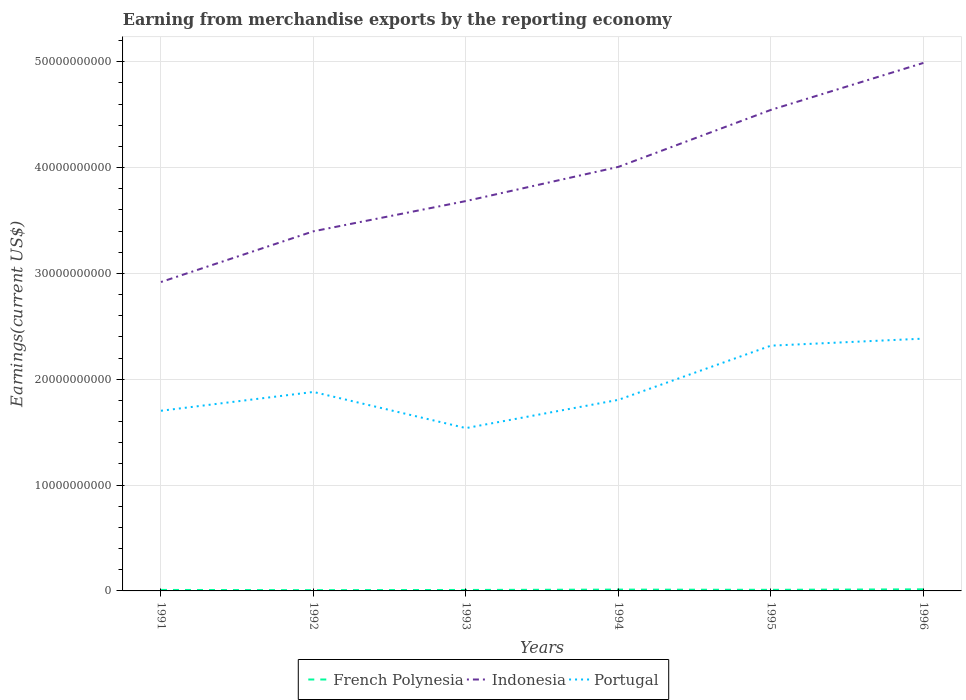Does the line corresponding to Indonesia intersect with the line corresponding to French Polynesia?
Your answer should be very brief. No. Is the number of lines equal to the number of legend labels?
Offer a very short reply. Yes. Across all years, what is the maximum amount earned from merchandise exports in Indonesia?
Your response must be concise. 2.92e+1. In which year was the amount earned from merchandise exports in French Polynesia maximum?
Your answer should be very brief. 1992. What is the total amount earned from merchandise exports in French Polynesia in the graph?
Keep it short and to the point. -1.26e+07. What is the difference between the highest and the second highest amount earned from merchandise exports in Portugal?
Your response must be concise. 8.45e+09. What is the difference between the highest and the lowest amount earned from merchandise exports in Portugal?
Your answer should be compact. 2. Is the amount earned from merchandise exports in French Polynesia strictly greater than the amount earned from merchandise exports in Portugal over the years?
Your response must be concise. Yes. How many lines are there?
Provide a succinct answer. 3. How many years are there in the graph?
Provide a succinct answer. 6. Does the graph contain any zero values?
Ensure brevity in your answer.  No. Does the graph contain grids?
Make the answer very short. Yes. Where does the legend appear in the graph?
Provide a short and direct response. Bottom center. How are the legend labels stacked?
Ensure brevity in your answer.  Horizontal. What is the title of the graph?
Your answer should be compact. Earning from merchandise exports by the reporting economy. What is the label or title of the X-axis?
Provide a short and direct response. Years. What is the label or title of the Y-axis?
Provide a succinct answer. Earnings(current US$). What is the Earnings(current US$) in French Polynesia in 1991?
Give a very brief answer. 9.38e+07. What is the Earnings(current US$) of Indonesia in 1991?
Offer a very short reply. 2.92e+1. What is the Earnings(current US$) in Portugal in 1991?
Offer a very short reply. 1.70e+1. What is the Earnings(current US$) in French Polynesia in 1992?
Provide a succinct answer. 7.24e+07. What is the Earnings(current US$) in Indonesia in 1992?
Offer a terse response. 3.40e+1. What is the Earnings(current US$) of Portugal in 1992?
Your answer should be compact. 1.88e+1. What is the Earnings(current US$) in French Polynesia in 1993?
Offer a terse response. 9.19e+07. What is the Earnings(current US$) of Indonesia in 1993?
Offer a terse response. 3.68e+1. What is the Earnings(current US$) of Portugal in 1993?
Give a very brief answer. 1.54e+1. What is the Earnings(current US$) of French Polynesia in 1994?
Give a very brief answer. 1.24e+08. What is the Earnings(current US$) in Indonesia in 1994?
Your response must be concise. 4.01e+1. What is the Earnings(current US$) in Portugal in 1994?
Your answer should be very brief. 1.81e+1. What is the Earnings(current US$) of French Polynesia in 1995?
Provide a short and direct response. 1.05e+08. What is the Earnings(current US$) in Indonesia in 1995?
Make the answer very short. 4.55e+1. What is the Earnings(current US$) of Portugal in 1995?
Your response must be concise. 2.32e+1. What is the Earnings(current US$) of French Polynesia in 1996?
Your answer should be very brief. 1.50e+08. What is the Earnings(current US$) in Indonesia in 1996?
Offer a terse response. 4.99e+1. What is the Earnings(current US$) of Portugal in 1996?
Your answer should be compact. 2.38e+1. Across all years, what is the maximum Earnings(current US$) in French Polynesia?
Keep it short and to the point. 1.50e+08. Across all years, what is the maximum Earnings(current US$) of Indonesia?
Your response must be concise. 4.99e+1. Across all years, what is the maximum Earnings(current US$) in Portugal?
Provide a succinct answer. 2.38e+1. Across all years, what is the minimum Earnings(current US$) of French Polynesia?
Give a very brief answer. 7.24e+07. Across all years, what is the minimum Earnings(current US$) of Indonesia?
Your response must be concise. 2.92e+1. Across all years, what is the minimum Earnings(current US$) in Portugal?
Your answer should be very brief. 1.54e+1. What is the total Earnings(current US$) in French Polynesia in the graph?
Offer a very short reply. 6.37e+08. What is the total Earnings(current US$) of Indonesia in the graph?
Provide a short and direct response. 2.35e+11. What is the total Earnings(current US$) of Portugal in the graph?
Your answer should be compact. 1.16e+11. What is the difference between the Earnings(current US$) of French Polynesia in 1991 and that in 1992?
Your answer should be very brief. 2.13e+07. What is the difference between the Earnings(current US$) in Indonesia in 1991 and that in 1992?
Offer a terse response. -4.79e+09. What is the difference between the Earnings(current US$) in Portugal in 1991 and that in 1992?
Give a very brief answer. -1.78e+09. What is the difference between the Earnings(current US$) in French Polynesia in 1991 and that in 1993?
Offer a terse response. 1.85e+06. What is the difference between the Earnings(current US$) in Indonesia in 1991 and that in 1993?
Your answer should be compact. -7.65e+09. What is the difference between the Earnings(current US$) of Portugal in 1991 and that in 1993?
Provide a succinct answer. 1.64e+09. What is the difference between the Earnings(current US$) of French Polynesia in 1991 and that in 1994?
Your answer should be compact. -3.02e+07. What is the difference between the Earnings(current US$) in Indonesia in 1991 and that in 1994?
Ensure brevity in your answer.  -1.09e+1. What is the difference between the Earnings(current US$) of Portugal in 1991 and that in 1994?
Offer a very short reply. -1.03e+09. What is the difference between the Earnings(current US$) of French Polynesia in 1991 and that in 1995?
Ensure brevity in your answer.  -1.08e+07. What is the difference between the Earnings(current US$) in Indonesia in 1991 and that in 1995?
Your response must be concise. -1.63e+1. What is the difference between the Earnings(current US$) in Portugal in 1991 and that in 1995?
Make the answer very short. -6.15e+09. What is the difference between the Earnings(current US$) in French Polynesia in 1991 and that in 1996?
Your response must be concise. -5.67e+07. What is the difference between the Earnings(current US$) in Indonesia in 1991 and that in 1996?
Your answer should be compact. -2.07e+1. What is the difference between the Earnings(current US$) of Portugal in 1991 and that in 1996?
Offer a terse response. -6.81e+09. What is the difference between the Earnings(current US$) in French Polynesia in 1992 and that in 1993?
Ensure brevity in your answer.  -1.95e+07. What is the difference between the Earnings(current US$) of Indonesia in 1992 and that in 1993?
Provide a short and direct response. -2.86e+09. What is the difference between the Earnings(current US$) in Portugal in 1992 and that in 1993?
Your answer should be very brief. 3.42e+09. What is the difference between the Earnings(current US$) of French Polynesia in 1992 and that in 1994?
Give a very brief answer. -5.15e+07. What is the difference between the Earnings(current US$) in Indonesia in 1992 and that in 1994?
Offer a terse response. -6.09e+09. What is the difference between the Earnings(current US$) in Portugal in 1992 and that in 1994?
Your response must be concise. 7.45e+08. What is the difference between the Earnings(current US$) of French Polynesia in 1992 and that in 1995?
Provide a succinct answer. -3.21e+07. What is the difference between the Earnings(current US$) in Indonesia in 1992 and that in 1995?
Make the answer very short. -1.15e+1. What is the difference between the Earnings(current US$) of Portugal in 1992 and that in 1995?
Provide a succinct answer. -4.37e+09. What is the difference between the Earnings(current US$) in French Polynesia in 1992 and that in 1996?
Offer a terse response. -7.80e+07. What is the difference between the Earnings(current US$) of Indonesia in 1992 and that in 1996?
Provide a short and direct response. -1.59e+1. What is the difference between the Earnings(current US$) in Portugal in 1992 and that in 1996?
Your response must be concise. -5.04e+09. What is the difference between the Earnings(current US$) of French Polynesia in 1993 and that in 1994?
Your answer should be compact. -3.21e+07. What is the difference between the Earnings(current US$) in Indonesia in 1993 and that in 1994?
Provide a short and direct response. -3.23e+09. What is the difference between the Earnings(current US$) in Portugal in 1993 and that in 1994?
Your answer should be very brief. -2.67e+09. What is the difference between the Earnings(current US$) in French Polynesia in 1993 and that in 1995?
Give a very brief answer. -1.26e+07. What is the difference between the Earnings(current US$) in Indonesia in 1993 and that in 1995?
Offer a terse response. -8.61e+09. What is the difference between the Earnings(current US$) of Portugal in 1993 and that in 1995?
Keep it short and to the point. -7.79e+09. What is the difference between the Earnings(current US$) of French Polynesia in 1993 and that in 1996?
Give a very brief answer. -5.85e+07. What is the difference between the Earnings(current US$) in Indonesia in 1993 and that in 1996?
Provide a succinct answer. -1.31e+1. What is the difference between the Earnings(current US$) in Portugal in 1993 and that in 1996?
Keep it short and to the point. -8.45e+09. What is the difference between the Earnings(current US$) in French Polynesia in 1994 and that in 1995?
Your response must be concise. 1.94e+07. What is the difference between the Earnings(current US$) of Indonesia in 1994 and that in 1995?
Your answer should be compact. -5.38e+09. What is the difference between the Earnings(current US$) in Portugal in 1994 and that in 1995?
Your answer should be very brief. -5.12e+09. What is the difference between the Earnings(current US$) in French Polynesia in 1994 and that in 1996?
Offer a very short reply. -2.65e+07. What is the difference between the Earnings(current US$) of Indonesia in 1994 and that in 1996?
Make the answer very short. -9.82e+09. What is the difference between the Earnings(current US$) of Portugal in 1994 and that in 1996?
Your answer should be very brief. -5.78e+09. What is the difference between the Earnings(current US$) in French Polynesia in 1995 and that in 1996?
Give a very brief answer. -4.59e+07. What is the difference between the Earnings(current US$) of Indonesia in 1995 and that in 1996?
Ensure brevity in your answer.  -4.44e+09. What is the difference between the Earnings(current US$) in Portugal in 1995 and that in 1996?
Provide a short and direct response. -6.64e+08. What is the difference between the Earnings(current US$) in French Polynesia in 1991 and the Earnings(current US$) in Indonesia in 1992?
Offer a very short reply. -3.39e+1. What is the difference between the Earnings(current US$) of French Polynesia in 1991 and the Earnings(current US$) of Portugal in 1992?
Keep it short and to the point. -1.87e+1. What is the difference between the Earnings(current US$) in Indonesia in 1991 and the Earnings(current US$) in Portugal in 1992?
Make the answer very short. 1.04e+1. What is the difference between the Earnings(current US$) of French Polynesia in 1991 and the Earnings(current US$) of Indonesia in 1993?
Your answer should be compact. -3.67e+1. What is the difference between the Earnings(current US$) of French Polynesia in 1991 and the Earnings(current US$) of Portugal in 1993?
Your answer should be compact. -1.53e+1. What is the difference between the Earnings(current US$) of Indonesia in 1991 and the Earnings(current US$) of Portugal in 1993?
Give a very brief answer. 1.38e+1. What is the difference between the Earnings(current US$) in French Polynesia in 1991 and the Earnings(current US$) in Indonesia in 1994?
Your answer should be compact. -4.00e+1. What is the difference between the Earnings(current US$) in French Polynesia in 1991 and the Earnings(current US$) in Portugal in 1994?
Your answer should be compact. -1.80e+1. What is the difference between the Earnings(current US$) of Indonesia in 1991 and the Earnings(current US$) of Portugal in 1994?
Your response must be concise. 1.11e+1. What is the difference between the Earnings(current US$) in French Polynesia in 1991 and the Earnings(current US$) in Indonesia in 1995?
Ensure brevity in your answer.  -4.54e+1. What is the difference between the Earnings(current US$) in French Polynesia in 1991 and the Earnings(current US$) in Portugal in 1995?
Make the answer very short. -2.31e+1. What is the difference between the Earnings(current US$) of Indonesia in 1991 and the Earnings(current US$) of Portugal in 1995?
Give a very brief answer. 6.01e+09. What is the difference between the Earnings(current US$) of French Polynesia in 1991 and the Earnings(current US$) of Indonesia in 1996?
Your answer should be compact. -4.98e+1. What is the difference between the Earnings(current US$) in French Polynesia in 1991 and the Earnings(current US$) in Portugal in 1996?
Make the answer very short. -2.37e+1. What is the difference between the Earnings(current US$) in Indonesia in 1991 and the Earnings(current US$) in Portugal in 1996?
Provide a succinct answer. 5.35e+09. What is the difference between the Earnings(current US$) of French Polynesia in 1992 and the Earnings(current US$) of Indonesia in 1993?
Your response must be concise. -3.68e+1. What is the difference between the Earnings(current US$) of French Polynesia in 1992 and the Earnings(current US$) of Portugal in 1993?
Give a very brief answer. -1.53e+1. What is the difference between the Earnings(current US$) of Indonesia in 1992 and the Earnings(current US$) of Portugal in 1993?
Your answer should be very brief. 1.86e+1. What is the difference between the Earnings(current US$) of French Polynesia in 1992 and the Earnings(current US$) of Indonesia in 1994?
Ensure brevity in your answer.  -4.00e+1. What is the difference between the Earnings(current US$) in French Polynesia in 1992 and the Earnings(current US$) in Portugal in 1994?
Offer a very short reply. -1.80e+1. What is the difference between the Earnings(current US$) of Indonesia in 1992 and the Earnings(current US$) of Portugal in 1994?
Offer a terse response. 1.59e+1. What is the difference between the Earnings(current US$) of French Polynesia in 1992 and the Earnings(current US$) of Indonesia in 1995?
Give a very brief answer. -4.54e+1. What is the difference between the Earnings(current US$) of French Polynesia in 1992 and the Earnings(current US$) of Portugal in 1995?
Provide a succinct answer. -2.31e+1. What is the difference between the Earnings(current US$) in Indonesia in 1992 and the Earnings(current US$) in Portugal in 1995?
Offer a terse response. 1.08e+1. What is the difference between the Earnings(current US$) of French Polynesia in 1992 and the Earnings(current US$) of Indonesia in 1996?
Provide a short and direct response. -4.98e+1. What is the difference between the Earnings(current US$) of French Polynesia in 1992 and the Earnings(current US$) of Portugal in 1996?
Offer a very short reply. -2.38e+1. What is the difference between the Earnings(current US$) in Indonesia in 1992 and the Earnings(current US$) in Portugal in 1996?
Provide a succinct answer. 1.01e+1. What is the difference between the Earnings(current US$) of French Polynesia in 1993 and the Earnings(current US$) of Indonesia in 1994?
Your response must be concise. -4.00e+1. What is the difference between the Earnings(current US$) of French Polynesia in 1993 and the Earnings(current US$) of Portugal in 1994?
Provide a short and direct response. -1.80e+1. What is the difference between the Earnings(current US$) of Indonesia in 1993 and the Earnings(current US$) of Portugal in 1994?
Keep it short and to the point. 1.88e+1. What is the difference between the Earnings(current US$) in French Polynesia in 1993 and the Earnings(current US$) in Indonesia in 1995?
Offer a terse response. -4.54e+1. What is the difference between the Earnings(current US$) in French Polynesia in 1993 and the Earnings(current US$) in Portugal in 1995?
Provide a short and direct response. -2.31e+1. What is the difference between the Earnings(current US$) in Indonesia in 1993 and the Earnings(current US$) in Portugal in 1995?
Provide a succinct answer. 1.37e+1. What is the difference between the Earnings(current US$) of French Polynesia in 1993 and the Earnings(current US$) of Indonesia in 1996?
Keep it short and to the point. -4.98e+1. What is the difference between the Earnings(current US$) in French Polynesia in 1993 and the Earnings(current US$) in Portugal in 1996?
Offer a terse response. -2.37e+1. What is the difference between the Earnings(current US$) of Indonesia in 1993 and the Earnings(current US$) of Portugal in 1996?
Keep it short and to the point. 1.30e+1. What is the difference between the Earnings(current US$) of French Polynesia in 1994 and the Earnings(current US$) of Indonesia in 1995?
Your answer should be compact. -4.53e+1. What is the difference between the Earnings(current US$) in French Polynesia in 1994 and the Earnings(current US$) in Portugal in 1995?
Your response must be concise. -2.31e+1. What is the difference between the Earnings(current US$) of Indonesia in 1994 and the Earnings(current US$) of Portugal in 1995?
Offer a very short reply. 1.69e+1. What is the difference between the Earnings(current US$) in French Polynesia in 1994 and the Earnings(current US$) in Indonesia in 1996?
Give a very brief answer. -4.98e+1. What is the difference between the Earnings(current US$) in French Polynesia in 1994 and the Earnings(current US$) in Portugal in 1996?
Provide a short and direct response. -2.37e+1. What is the difference between the Earnings(current US$) of Indonesia in 1994 and the Earnings(current US$) of Portugal in 1996?
Provide a succinct answer. 1.62e+1. What is the difference between the Earnings(current US$) in French Polynesia in 1995 and the Earnings(current US$) in Indonesia in 1996?
Make the answer very short. -4.98e+1. What is the difference between the Earnings(current US$) of French Polynesia in 1995 and the Earnings(current US$) of Portugal in 1996?
Keep it short and to the point. -2.37e+1. What is the difference between the Earnings(current US$) of Indonesia in 1995 and the Earnings(current US$) of Portugal in 1996?
Offer a very short reply. 2.16e+1. What is the average Earnings(current US$) of French Polynesia per year?
Provide a succinct answer. 1.06e+08. What is the average Earnings(current US$) in Indonesia per year?
Provide a succinct answer. 3.92e+1. What is the average Earnings(current US$) of Portugal per year?
Keep it short and to the point. 1.94e+1. In the year 1991, what is the difference between the Earnings(current US$) in French Polynesia and Earnings(current US$) in Indonesia?
Make the answer very short. -2.91e+1. In the year 1991, what is the difference between the Earnings(current US$) of French Polynesia and Earnings(current US$) of Portugal?
Provide a succinct answer. -1.69e+1. In the year 1991, what is the difference between the Earnings(current US$) of Indonesia and Earnings(current US$) of Portugal?
Keep it short and to the point. 1.22e+1. In the year 1992, what is the difference between the Earnings(current US$) in French Polynesia and Earnings(current US$) in Indonesia?
Provide a short and direct response. -3.39e+1. In the year 1992, what is the difference between the Earnings(current US$) of French Polynesia and Earnings(current US$) of Portugal?
Offer a terse response. -1.87e+1. In the year 1992, what is the difference between the Earnings(current US$) in Indonesia and Earnings(current US$) in Portugal?
Keep it short and to the point. 1.52e+1. In the year 1993, what is the difference between the Earnings(current US$) of French Polynesia and Earnings(current US$) of Indonesia?
Give a very brief answer. -3.67e+1. In the year 1993, what is the difference between the Earnings(current US$) of French Polynesia and Earnings(current US$) of Portugal?
Offer a terse response. -1.53e+1. In the year 1993, what is the difference between the Earnings(current US$) of Indonesia and Earnings(current US$) of Portugal?
Provide a short and direct response. 2.15e+1. In the year 1994, what is the difference between the Earnings(current US$) in French Polynesia and Earnings(current US$) in Indonesia?
Make the answer very short. -3.99e+1. In the year 1994, what is the difference between the Earnings(current US$) in French Polynesia and Earnings(current US$) in Portugal?
Your answer should be very brief. -1.79e+1. In the year 1994, what is the difference between the Earnings(current US$) in Indonesia and Earnings(current US$) in Portugal?
Give a very brief answer. 2.20e+1. In the year 1995, what is the difference between the Earnings(current US$) in French Polynesia and Earnings(current US$) in Indonesia?
Your response must be concise. -4.53e+1. In the year 1995, what is the difference between the Earnings(current US$) in French Polynesia and Earnings(current US$) in Portugal?
Keep it short and to the point. -2.31e+1. In the year 1995, what is the difference between the Earnings(current US$) in Indonesia and Earnings(current US$) in Portugal?
Make the answer very short. 2.23e+1. In the year 1996, what is the difference between the Earnings(current US$) in French Polynesia and Earnings(current US$) in Indonesia?
Your response must be concise. -4.97e+1. In the year 1996, what is the difference between the Earnings(current US$) of French Polynesia and Earnings(current US$) of Portugal?
Offer a terse response. -2.37e+1. In the year 1996, what is the difference between the Earnings(current US$) of Indonesia and Earnings(current US$) of Portugal?
Your answer should be very brief. 2.61e+1. What is the ratio of the Earnings(current US$) in French Polynesia in 1991 to that in 1992?
Your answer should be compact. 1.29. What is the ratio of the Earnings(current US$) of Indonesia in 1991 to that in 1992?
Your answer should be compact. 0.86. What is the ratio of the Earnings(current US$) of Portugal in 1991 to that in 1992?
Your answer should be compact. 0.91. What is the ratio of the Earnings(current US$) in French Polynesia in 1991 to that in 1993?
Keep it short and to the point. 1.02. What is the ratio of the Earnings(current US$) of Indonesia in 1991 to that in 1993?
Provide a succinct answer. 0.79. What is the ratio of the Earnings(current US$) in Portugal in 1991 to that in 1993?
Keep it short and to the point. 1.11. What is the ratio of the Earnings(current US$) in French Polynesia in 1991 to that in 1994?
Make the answer very short. 0.76. What is the ratio of the Earnings(current US$) in Indonesia in 1991 to that in 1994?
Provide a succinct answer. 0.73. What is the ratio of the Earnings(current US$) of Portugal in 1991 to that in 1994?
Ensure brevity in your answer.  0.94. What is the ratio of the Earnings(current US$) of French Polynesia in 1991 to that in 1995?
Make the answer very short. 0.9. What is the ratio of the Earnings(current US$) of Indonesia in 1991 to that in 1995?
Your response must be concise. 0.64. What is the ratio of the Earnings(current US$) in Portugal in 1991 to that in 1995?
Your response must be concise. 0.73. What is the ratio of the Earnings(current US$) in French Polynesia in 1991 to that in 1996?
Offer a very short reply. 0.62. What is the ratio of the Earnings(current US$) of Indonesia in 1991 to that in 1996?
Provide a succinct answer. 0.59. What is the ratio of the Earnings(current US$) of Portugal in 1991 to that in 1996?
Your answer should be compact. 0.71. What is the ratio of the Earnings(current US$) of French Polynesia in 1992 to that in 1993?
Ensure brevity in your answer.  0.79. What is the ratio of the Earnings(current US$) of Indonesia in 1992 to that in 1993?
Provide a short and direct response. 0.92. What is the ratio of the Earnings(current US$) in Portugal in 1992 to that in 1993?
Provide a succinct answer. 1.22. What is the ratio of the Earnings(current US$) of French Polynesia in 1992 to that in 1994?
Your answer should be very brief. 0.58. What is the ratio of the Earnings(current US$) in Indonesia in 1992 to that in 1994?
Provide a short and direct response. 0.85. What is the ratio of the Earnings(current US$) in Portugal in 1992 to that in 1994?
Your answer should be very brief. 1.04. What is the ratio of the Earnings(current US$) in French Polynesia in 1992 to that in 1995?
Provide a succinct answer. 0.69. What is the ratio of the Earnings(current US$) in Indonesia in 1992 to that in 1995?
Ensure brevity in your answer.  0.75. What is the ratio of the Earnings(current US$) of Portugal in 1992 to that in 1995?
Keep it short and to the point. 0.81. What is the ratio of the Earnings(current US$) of French Polynesia in 1992 to that in 1996?
Keep it short and to the point. 0.48. What is the ratio of the Earnings(current US$) in Indonesia in 1992 to that in 1996?
Your response must be concise. 0.68. What is the ratio of the Earnings(current US$) of Portugal in 1992 to that in 1996?
Your answer should be very brief. 0.79. What is the ratio of the Earnings(current US$) of French Polynesia in 1993 to that in 1994?
Make the answer very short. 0.74. What is the ratio of the Earnings(current US$) in Indonesia in 1993 to that in 1994?
Keep it short and to the point. 0.92. What is the ratio of the Earnings(current US$) of Portugal in 1993 to that in 1994?
Offer a terse response. 0.85. What is the ratio of the Earnings(current US$) in French Polynesia in 1993 to that in 1995?
Your response must be concise. 0.88. What is the ratio of the Earnings(current US$) of Indonesia in 1993 to that in 1995?
Make the answer very short. 0.81. What is the ratio of the Earnings(current US$) in Portugal in 1993 to that in 1995?
Your answer should be very brief. 0.66. What is the ratio of the Earnings(current US$) in French Polynesia in 1993 to that in 1996?
Your answer should be compact. 0.61. What is the ratio of the Earnings(current US$) of Indonesia in 1993 to that in 1996?
Your answer should be very brief. 0.74. What is the ratio of the Earnings(current US$) in Portugal in 1993 to that in 1996?
Offer a very short reply. 0.65. What is the ratio of the Earnings(current US$) in French Polynesia in 1994 to that in 1995?
Keep it short and to the point. 1.19. What is the ratio of the Earnings(current US$) in Indonesia in 1994 to that in 1995?
Ensure brevity in your answer.  0.88. What is the ratio of the Earnings(current US$) in Portugal in 1994 to that in 1995?
Offer a very short reply. 0.78. What is the ratio of the Earnings(current US$) in French Polynesia in 1994 to that in 1996?
Provide a short and direct response. 0.82. What is the ratio of the Earnings(current US$) of Indonesia in 1994 to that in 1996?
Ensure brevity in your answer.  0.8. What is the ratio of the Earnings(current US$) in Portugal in 1994 to that in 1996?
Offer a terse response. 0.76. What is the ratio of the Earnings(current US$) in French Polynesia in 1995 to that in 1996?
Your response must be concise. 0.69. What is the ratio of the Earnings(current US$) in Indonesia in 1995 to that in 1996?
Provide a short and direct response. 0.91. What is the ratio of the Earnings(current US$) in Portugal in 1995 to that in 1996?
Provide a succinct answer. 0.97. What is the difference between the highest and the second highest Earnings(current US$) in French Polynesia?
Ensure brevity in your answer.  2.65e+07. What is the difference between the highest and the second highest Earnings(current US$) in Indonesia?
Your answer should be very brief. 4.44e+09. What is the difference between the highest and the second highest Earnings(current US$) of Portugal?
Offer a terse response. 6.64e+08. What is the difference between the highest and the lowest Earnings(current US$) in French Polynesia?
Make the answer very short. 7.80e+07. What is the difference between the highest and the lowest Earnings(current US$) of Indonesia?
Provide a succinct answer. 2.07e+1. What is the difference between the highest and the lowest Earnings(current US$) in Portugal?
Ensure brevity in your answer.  8.45e+09. 